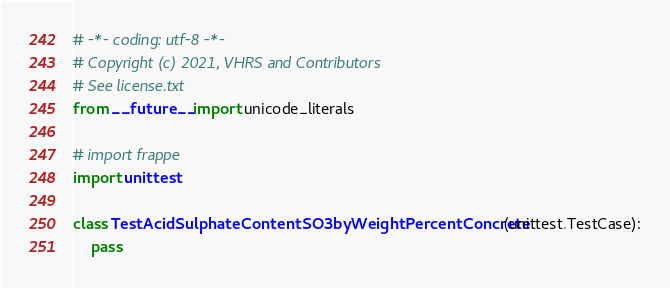<code> <loc_0><loc_0><loc_500><loc_500><_Python_># -*- coding: utf-8 -*-
# Copyright (c) 2021, VHRS and Contributors
# See license.txt
from __future__ import unicode_literals

# import frappe
import unittest

class TestAcidSulphateContentSO3byWeightPercentConcrete(unittest.TestCase):
	pass
</code> 